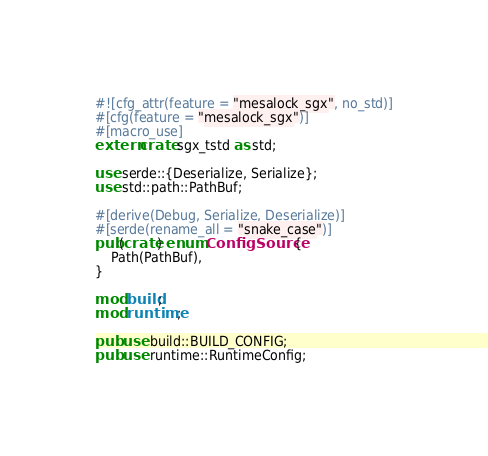<code> <loc_0><loc_0><loc_500><loc_500><_Rust_>#![cfg_attr(feature = "mesalock_sgx", no_std)]
#[cfg(feature = "mesalock_sgx")]
#[macro_use]
extern crate sgx_tstd as std;

use serde::{Deserialize, Serialize};
use std::path::PathBuf;

#[derive(Debug, Serialize, Deserialize)]
#[serde(rename_all = "snake_case")]
pub(crate) enum ConfigSource {
    Path(PathBuf),
}

mod build;
mod runtime;

pub use build::BUILD_CONFIG;
pub use runtime::RuntimeConfig;
</code> 